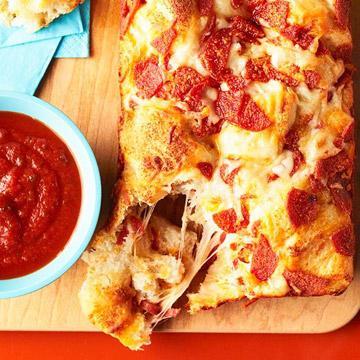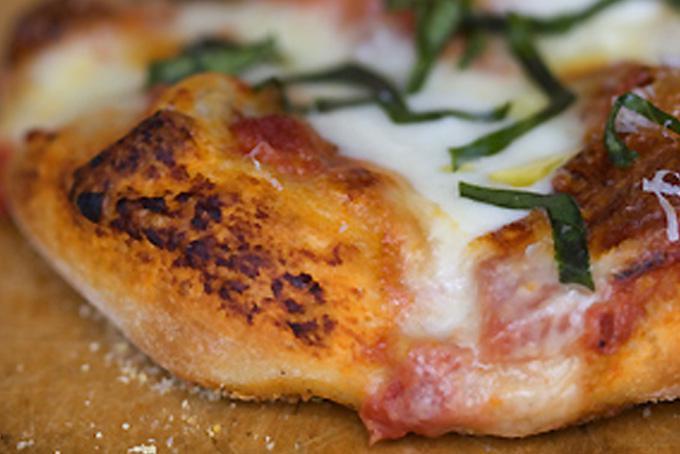The first image is the image on the left, the second image is the image on the right. For the images shown, is this caption "The right image shows an oblong loaf with pepperoni sticking out of criss-cross cuts, and the left image includes at least one rectangular shape with pepperonis and melted cheese on top." true? Answer yes or no. No. The first image is the image on the left, the second image is the image on the right. Evaluate the accuracy of this statement regarding the images: "In at least one image there is pepperoni pizza bread with marinara sauce to the left of the bread.". Is it true? Answer yes or no. Yes. 